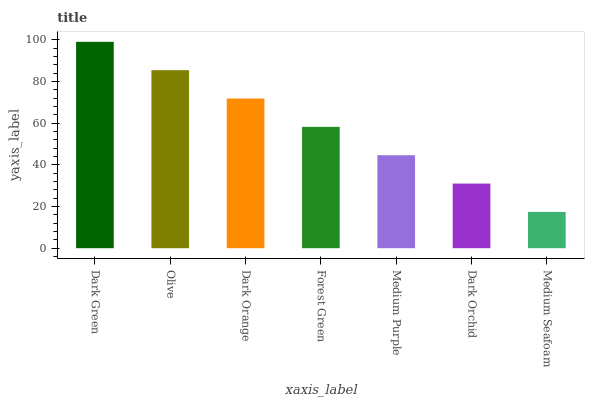Is Olive the minimum?
Answer yes or no. No. Is Olive the maximum?
Answer yes or no. No. Is Dark Green greater than Olive?
Answer yes or no. Yes. Is Olive less than Dark Green?
Answer yes or no. Yes. Is Olive greater than Dark Green?
Answer yes or no. No. Is Dark Green less than Olive?
Answer yes or no. No. Is Forest Green the high median?
Answer yes or no. Yes. Is Forest Green the low median?
Answer yes or no. Yes. Is Dark Orange the high median?
Answer yes or no. No. Is Dark Orchid the low median?
Answer yes or no. No. 